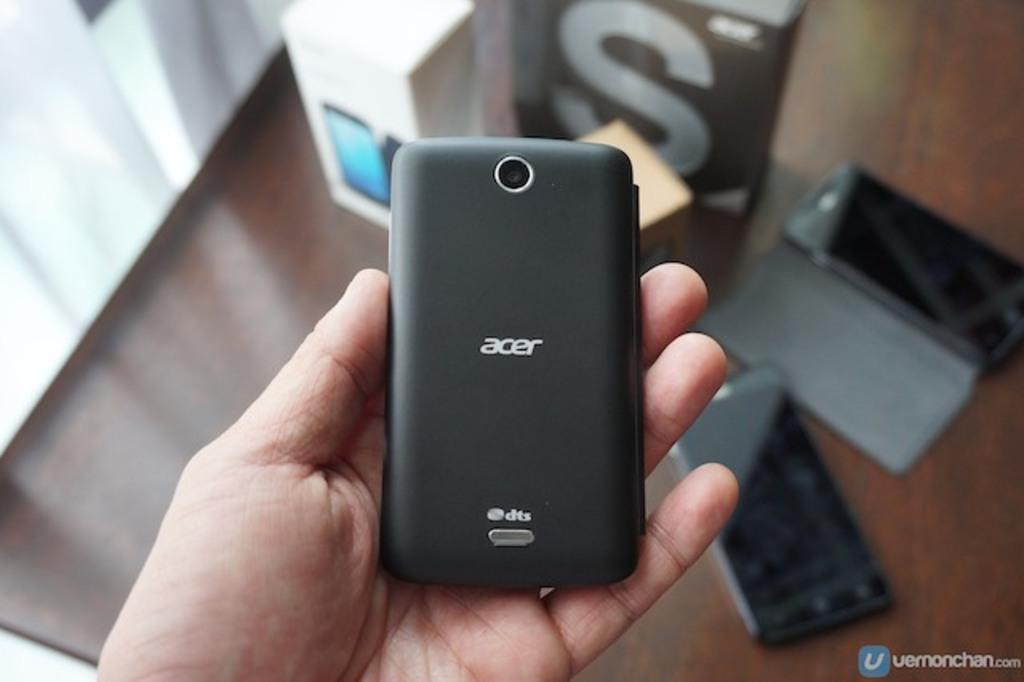What brand of phone is this?
Your response must be concise. Acer. What is the webpage printed in the lower right corner?
Keep it short and to the point. Vernonchan.com. 